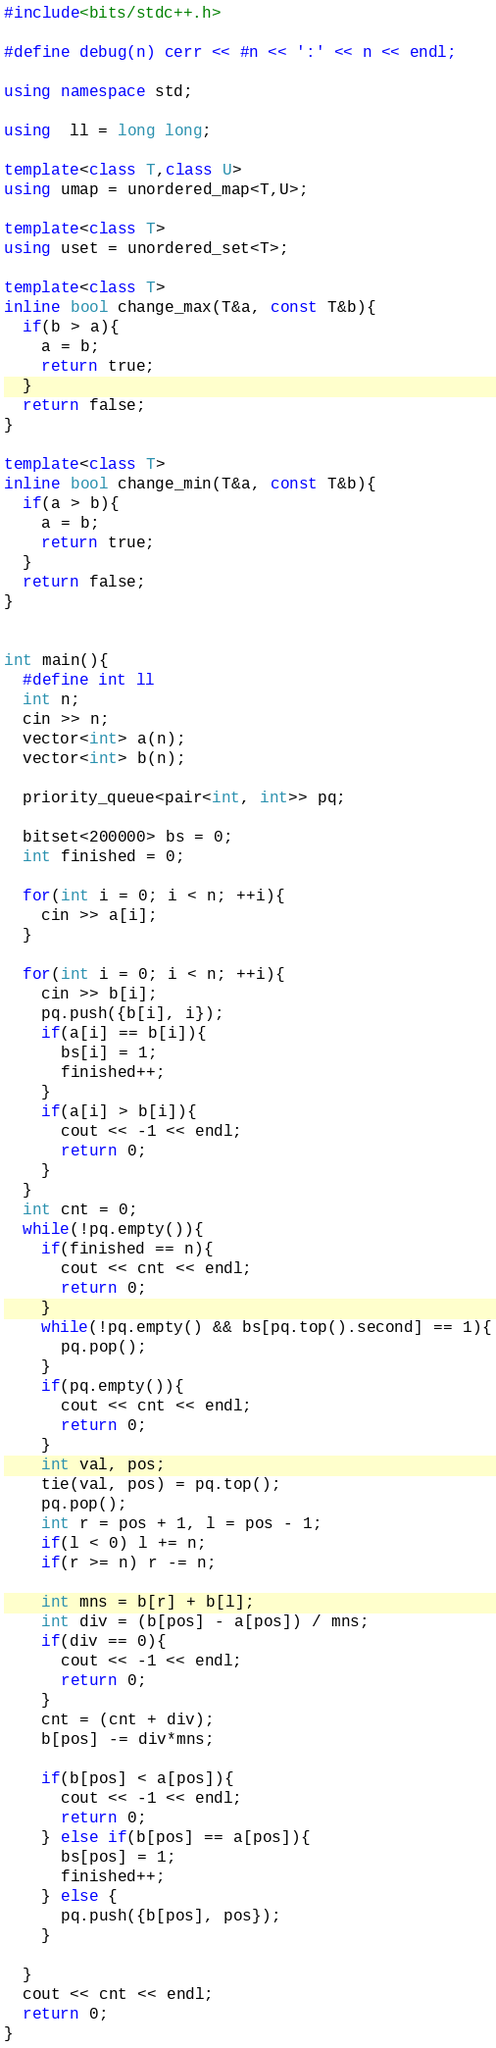Convert code to text. <code><loc_0><loc_0><loc_500><loc_500><_C++_>#include<bits/stdc++.h>

#define debug(n) cerr << #n << ':' << n << endl;

using namespace std;

using  ll = long long;

template<class T,class U>
using umap = unordered_map<T,U>;

template<class T>
using uset = unordered_set<T>;

template<class T>
inline bool change_max(T&a, const T&b){
  if(b > a){
    a = b;
    return true;
  }
  return false;
}

template<class T>
inline bool change_min(T&a, const T&b){
  if(a > b){
    a = b;
    return true;
  }
  return false;
}


int main(){
  #define int ll
  int n;
  cin >> n;
  vector<int> a(n);
  vector<int> b(n);

  priority_queue<pair<int, int>> pq;

  bitset<200000> bs = 0;
  int finished = 0;
  
  for(int i = 0; i < n; ++i){
    cin >> a[i];
  }

  for(int i = 0; i < n; ++i){
    cin >> b[i];
    pq.push({b[i], i});
    if(a[i] == b[i]){
      bs[i] = 1;
      finished++;
    }
    if(a[i] > b[i]){
      cout << -1 << endl;
      return 0;
    }
  }
  int cnt = 0;
  while(!pq.empty()){
    if(finished == n){
      cout << cnt << endl;
      return 0;
    }
    while(!pq.empty() && bs[pq.top().second] == 1){
      pq.pop();
    }
    if(pq.empty()){
      cout << cnt << endl;
      return 0;
    }
    int val, pos;
    tie(val, pos) = pq.top();
    pq.pop();
    int r = pos + 1, l = pos - 1;
    if(l < 0) l += n;
    if(r >= n) r -= n;

    int mns = b[r] + b[l];
    int div = (b[pos] - a[pos]) / mns;
    if(div == 0){
      cout << -1 << endl;
      return 0;
    }
    cnt = (cnt + div);
    b[pos] -= div*mns;
    
    if(b[pos] < a[pos]){
      cout << -1 << endl;
      return 0;
    } else if(b[pos] == a[pos]){
      bs[pos] = 1;
      finished++;
    } else {
      pq.push({b[pos], pos});
    }
    
  }
  cout << cnt << endl;
  return 0;
}
</code> 